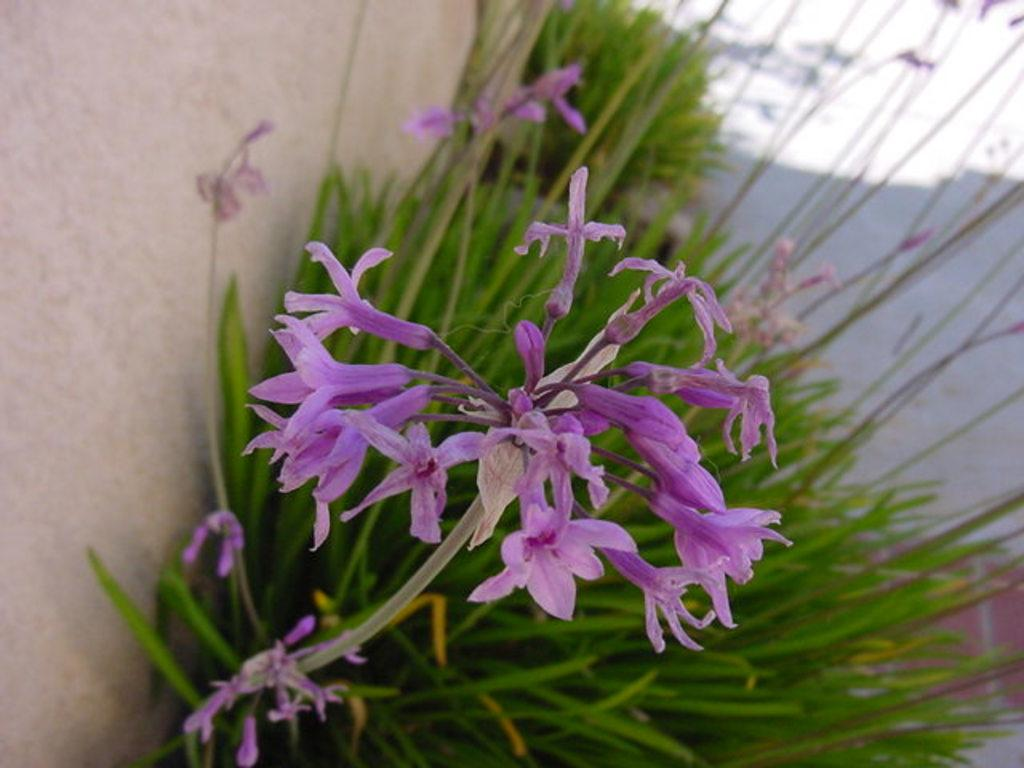What types of living organisms can be seen in the image? Plants and flowers are visible in the image. Can you describe the specific plants or flowers in the image? Unfortunately, the facts provided do not give specific details about the plants or flowers in the image. What might be the purpose of having plants and flowers in the image? The presence of plants and flowers in the image could be for decorative purposes, to create a natural or calming atmosphere, or to represent growth and life. Where can you buy the bucket of friends in the image? There is no bucket or friends present in the image, so it cannot be purchased. 